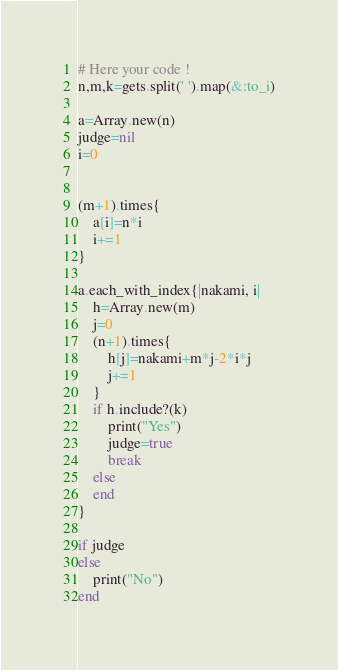Convert code to text. <code><loc_0><loc_0><loc_500><loc_500><_Ruby_># Here your code !
n,m,k=gets.split(' ').map(&:to_i)

a=Array.new(n)
judge=nil
i=0


(m+1).times{
    a[i]=n*i
    i+=1
}

a.each_with_index{|nakami, i|
    h=Array.new(m)
    j=0
    (n+1).times{
        h[j]=nakami+m*j-2*i*j
        j+=1
    }
    if h.include?(k)
        print("Yes")
        judge=true
        break
    else
    end
}

if judge
else
    print("No")
end


</code> 